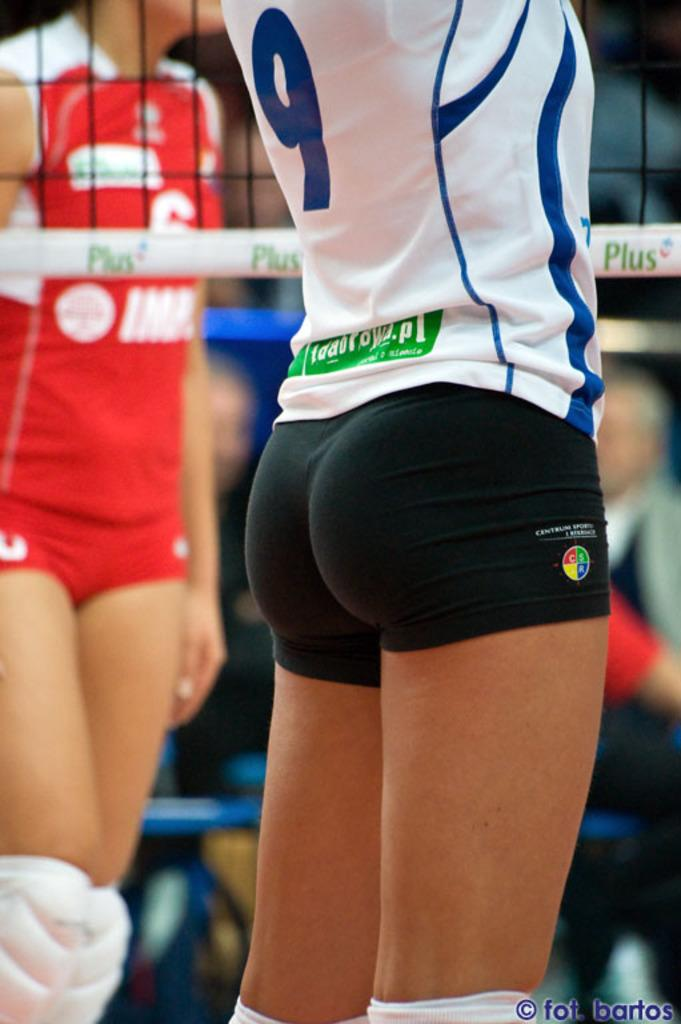<image>
Describe the image concisely. ladies volleyball game with a closeup on the butt of number 9 